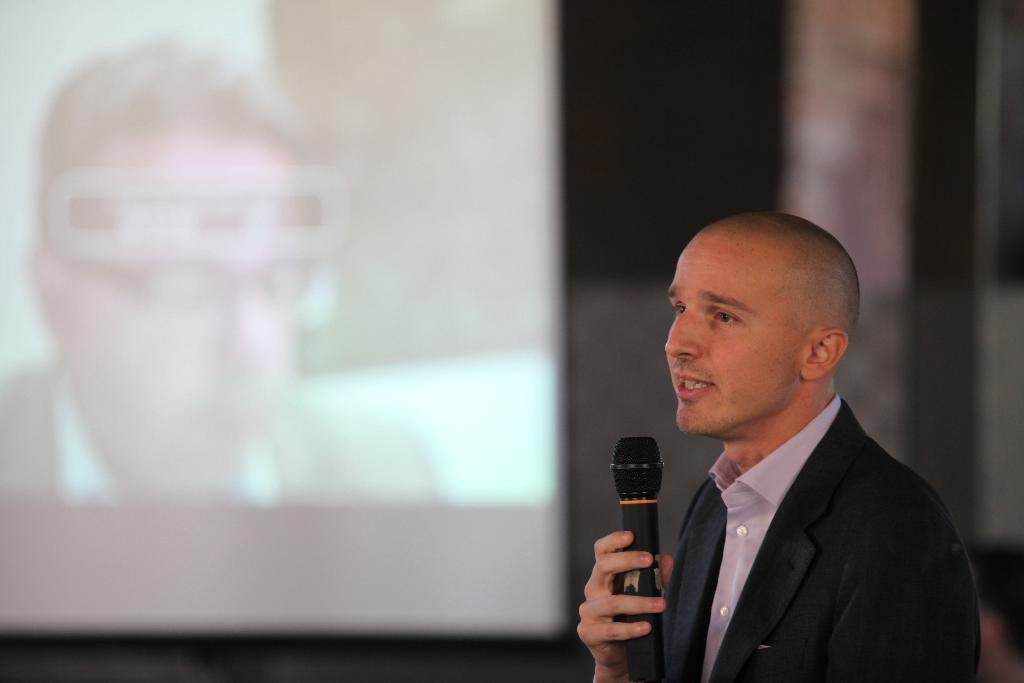Who is the person in the image? There is a man in the image. What is the man wearing? The man is wearing a blazer. What is the man holding in the image? The man is holding a microphone. What is the man doing in the image? The man is talking. What can be seen in the background of the image? There is a screen in the background of the image. What type of friction can be seen between the man and the microphone in the image? There is no friction visible between the man and the microphone in the image. How many rats are present in the image? There are no rats present in the image. 